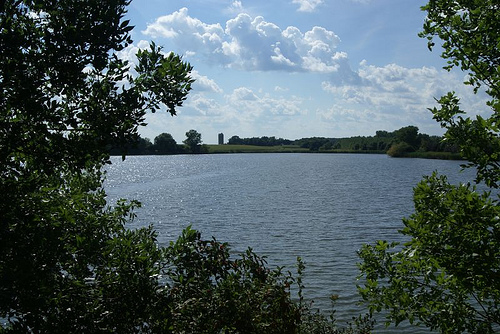<image>
Can you confirm if the lake is on the plants? No. The lake is not positioned on the plants. They may be near each other, but the lake is not supported by or resting on top of the plants. 